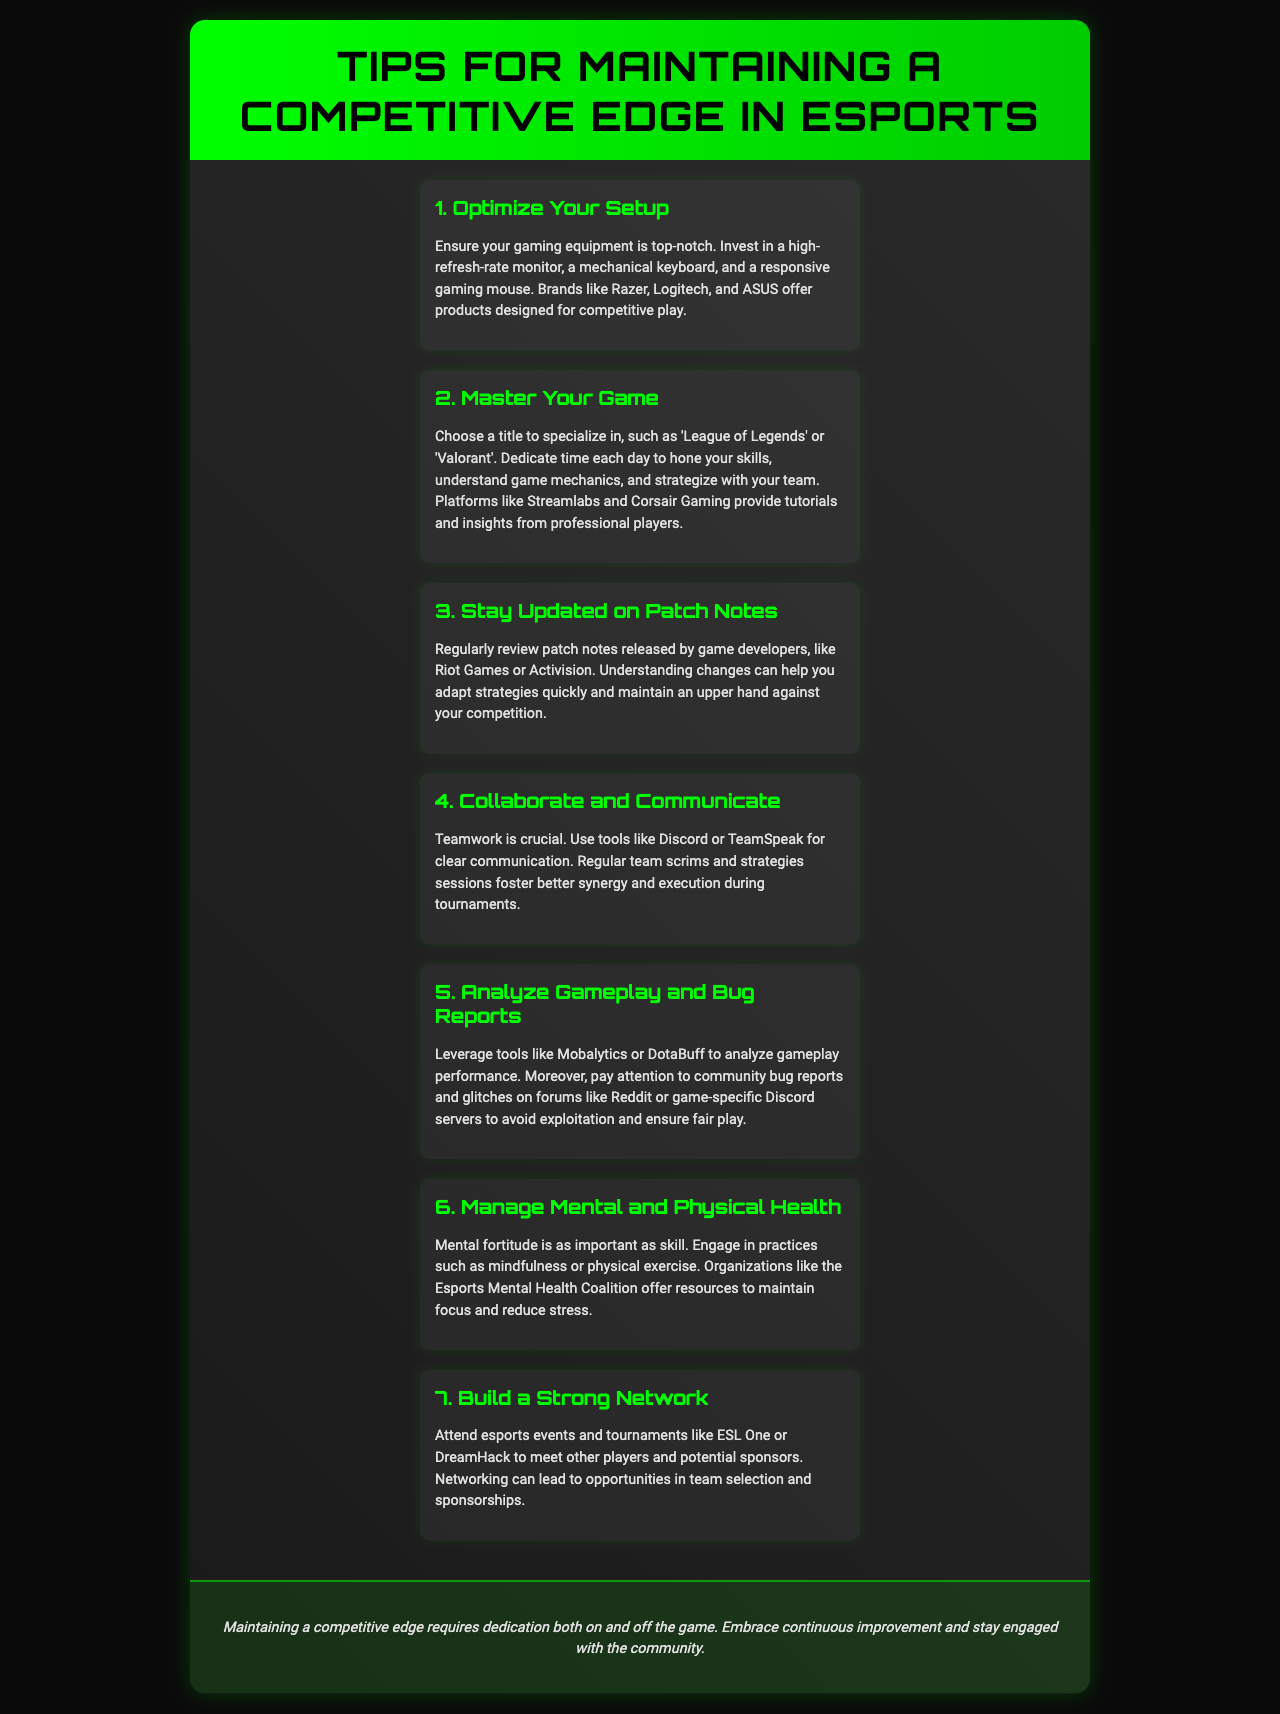What is the title of the brochure? The title is stated at the top of the document, indicating the brochure's main topic.
Answer: Tips for Maintaining a Competitive Edge in Esports How many main sections are there in the brochure? The brochure outlines distinct sections, each focused on a specific area of maintaining a competitive edge.
Answer: 7 What should you invest in to optimize your setup? The document emphasizes specific equipment that enhances gaming performance.
Answer: High-refresh-rate monitor, mechanical keyboard, gaming mouse Which platforms provide tutorials and insights from professional players? The document mentions platforms where players can gain knowledge about their game.
Answer: Streamlabs and Corsair Gaming What is crucial for maintaining teamwork according to the document? The document highlights tools essential for effective communication among team members.
Answer: Discord or TeamSpeak What organizations offer resources for mental health in esports? The document refers to an organization dedicated to supporting mental well-being in the esports community.
Answer: Esports Mental Health Coalition What should players regularly review to stay updated? The document advises players to keep track of updates released by game developers.
Answer: Patch notes 